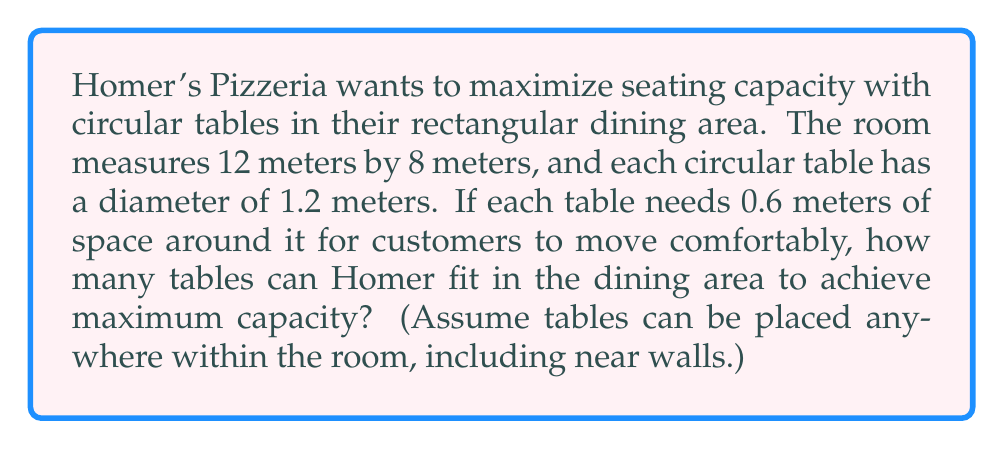Show me your answer to this math problem. Let's approach this step-by-step:

1) First, we need to calculate the effective area each table occupies:
   - Table diameter: 1.2 m
   - Required space around: 0.6 m on each side
   - Total effective diameter: $1.2 + 2(0.6) = 2.4$ m
   - Effective area per table: $A = \pi r^2 = \pi (1.2)^2 \approx 4.52$ m²

2) Now, let's calculate the total area of the dining room:
   $A_{room} = 12 \text{ m} \times 8 \text{ m} = 96$ m²

3) To find the maximum number of tables, we divide the room area by the effective area per table:
   $N = \frac{A_{room}}{A_{table}} = \frac{96}{4.52} \approx 21.24$

4) Since we can't have a fractional number of tables, we round down to the nearest whole number.

5) To verify, let's visualize the arrangement:

[asy]
size(200);
draw(box((0,0),(120,80)));
for(int i=0; i<=120; i+=24)
  for(int j=0; j<=80; j+=24)
    draw(circle((i,j),12));
[/asy]

This diagram shows that 20 tables (5 rows of 4) fit comfortably within the space.
Answer: 20 tables 